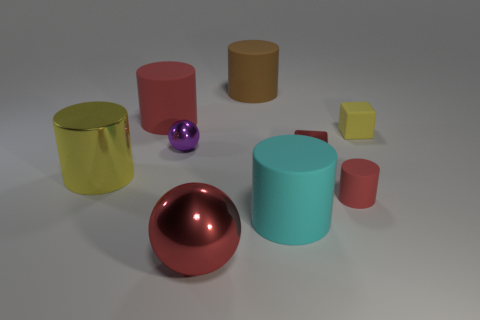Is there a big yellow cylinder?
Provide a succinct answer. Yes. The matte cylinder that is behind the red cylinder that is behind the yellow thing right of the red sphere is what color?
Provide a succinct answer. Brown. Are there any yellow objects that are in front of the yellow thing on the right side of the red metallic block?
Your response must be concise. Yes. There is a metal object in front of the large yellow object; is its color the same as the large matte cylinder on the left side of the tiny metallic sphere?
Give a very brief answer. Yes. What number of rubber cubes are the same size as the cyan rubber cylinder?
Make the answer very short. 0. There is a red metallic object in front of the shiny block; is it the same size as the tiny red metallic cube?
Make the answer very short. No. What is the shape of the small red matte thing?
Keep it short and to the point. Cylinder. There is a matte cube that is the same color as the large metal cylinder; what is its size?
Make the answer very short. Small. Is the small block on the left side of the yellow block made of the same material as the small sphere?
Your answer should be very brief. Yes. Is there another shiny cube of the same color as the shiny cube?
Offer a terse response. No. 